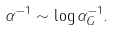Convert formula to latex. <formula><loc_0><loc_0><loc_500><loc_500>\alpha ^ { - 1 } \sim \log \alpha _ { G } ^ { - 1 } .</formula> 